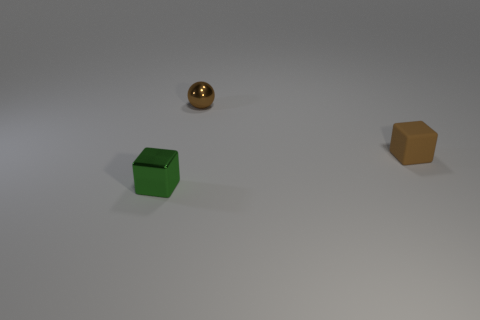Add 1 small cubes. How many objects exist? 4 Subtract 1 cubes. How many cubes are left? 1 Add 2 rubber cubes. How many rubber cubes are left? 3 Add 2 tiny spheres. How many tiny spheres exist? 3 Subtract 1 brown balls. How many objects are left? 2 Subtract all spheres. How many objects are left? 2 Subtract all blue cubes. Subtract all purple balls. How many cubes are left? 2 Subtract all green spheres. How many brown blocks are left? 1 Subtract all green metal blocks. Subtract all green objects. How many objects are left? 1 